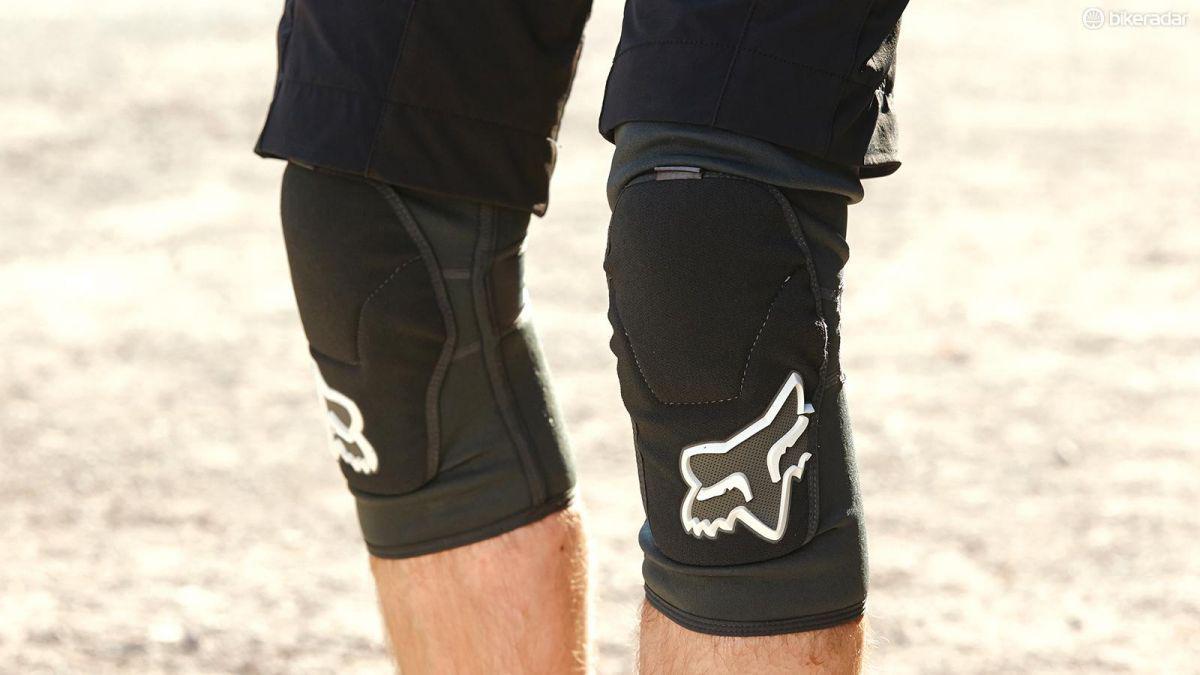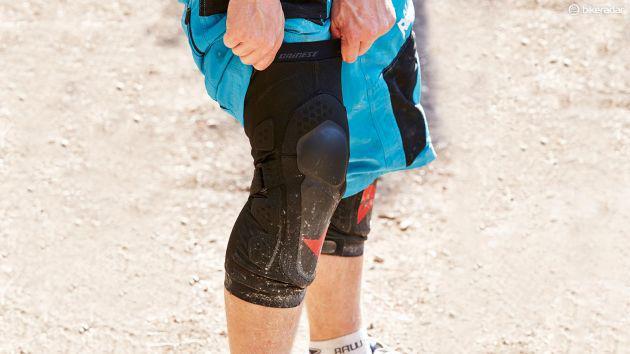The first image is the image on the left, the second image is the image on the right. Evaluate the accuracy of this statement regarding the images: "There are two pairs of legs.". Is it true? Answer yes or no. Yes. The first image is the image on the left, the second image is the image on the right. Given the left and right images, does the statement "There are exactly four legs visible." hold true? Answer yes or no. Yes. 